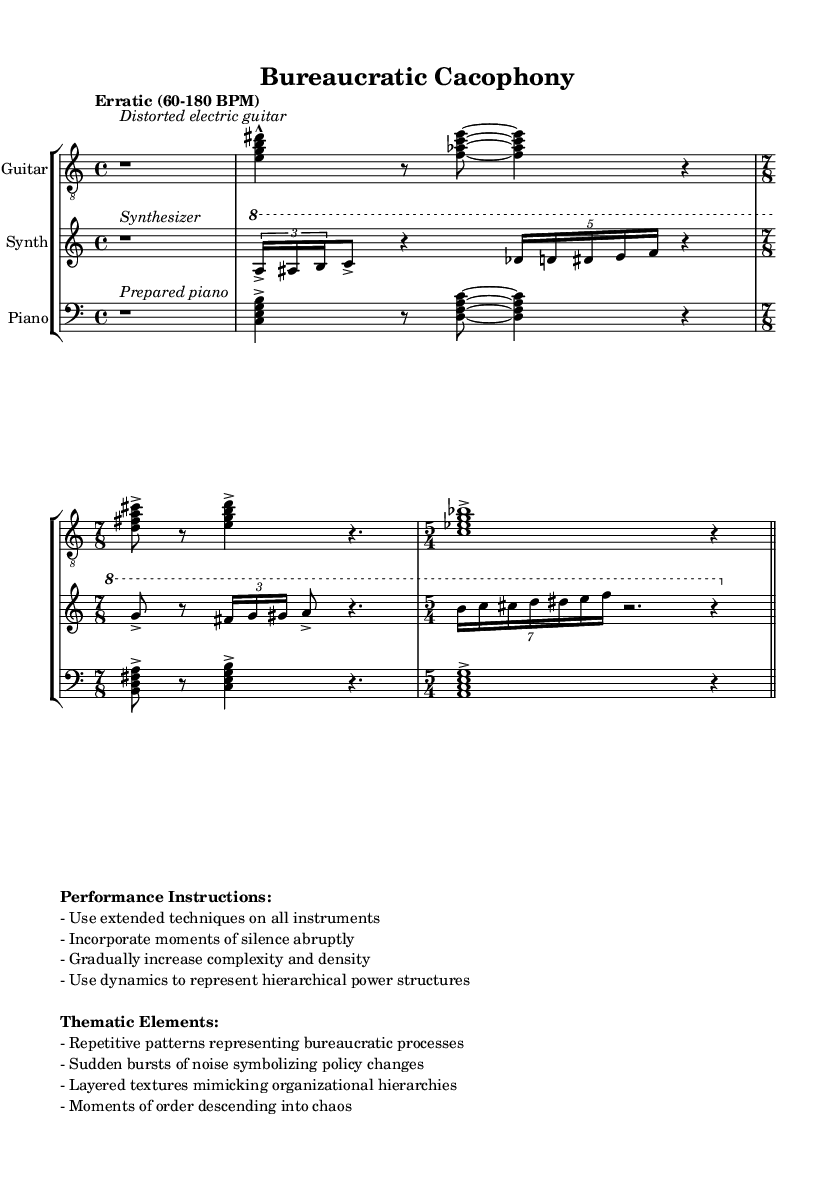What is the time signature of the first section in the guitar part? The first section of the guitar part is marked with a time signature of 4/4, which is indicated at the beginning of the score.
Answer: 4/4 What is the tempo instruction for this piece? The tempo instruction is provided as "Erratic (60-180 BPM)", indicating a range for how fast the music should be played.
Answer: Erratic (60-180 BPM) How many measures are there in the synthesizer part? Counting from the end of the first section to the end of the synthesizer part indicates there are a total of six measures, including transitions between different time signatures.
Answer: 6 What dynamic representation is suggested for the hierarchical power structures? The performance instructions state to use dynamics to represent hierarchical power structures, which implies variable levels of loudness are incorporated as part of the dynamics in the score.
Answer: Dynamics What are the thematic elements representing bureaucratic processes? The thematic elements in the performance instructions mention "Repetitive patterns representing bureaucratic processes," referring to the way the music is structured to reflect systems of organization and order.
Answer: Repetitive patterns In which musical section is the prepared piano to be utilized? The prepared piano is indicated directly at the beginning of the piano part, highlighting its unique role in the piece and the specific section it appears in.
Answer: Piano part What is the function of sudden bursts of noise as mentioned in thematic elements? The sudden bursts of noise symbolize policy changes, conveying abrupt, unexpected shifts in the sound and representing changes within the bureaucratic environment in the music.
Answer: Policy changes 